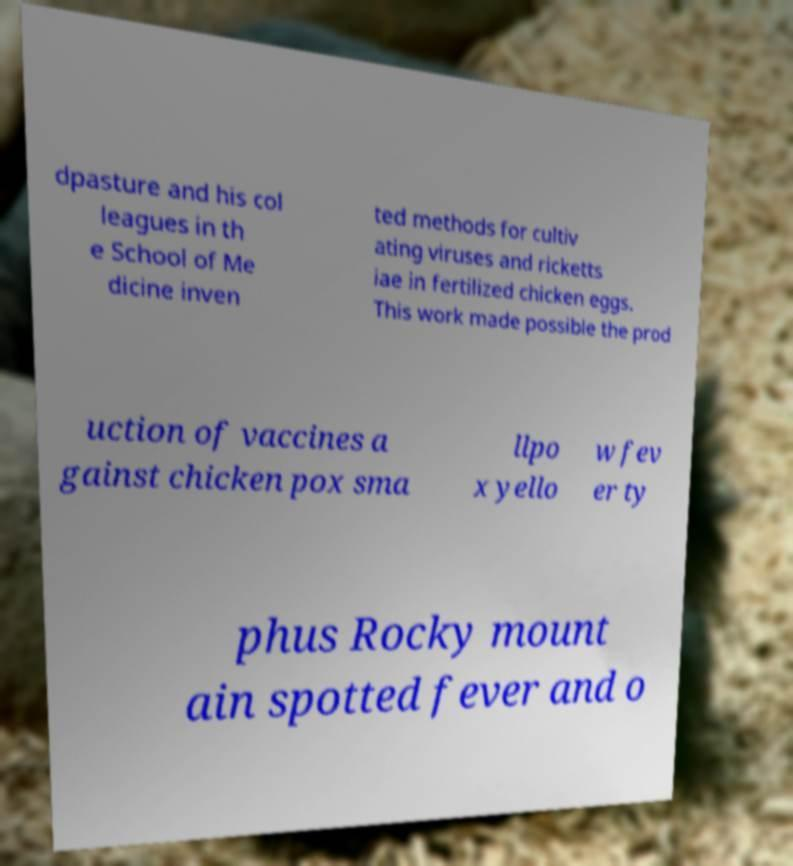Could you extract and type out the text from this image? dpasture and his col leagues in th e School of Me dicine inven ted methods for cultiv ating viruses and ricketts iae in fertilized chicken eggs. This work made possible the prod uction of vaccines a gainst chicken pox sma llpo x yello w fev er ty phus Rocky mount ain spotted fever and o 